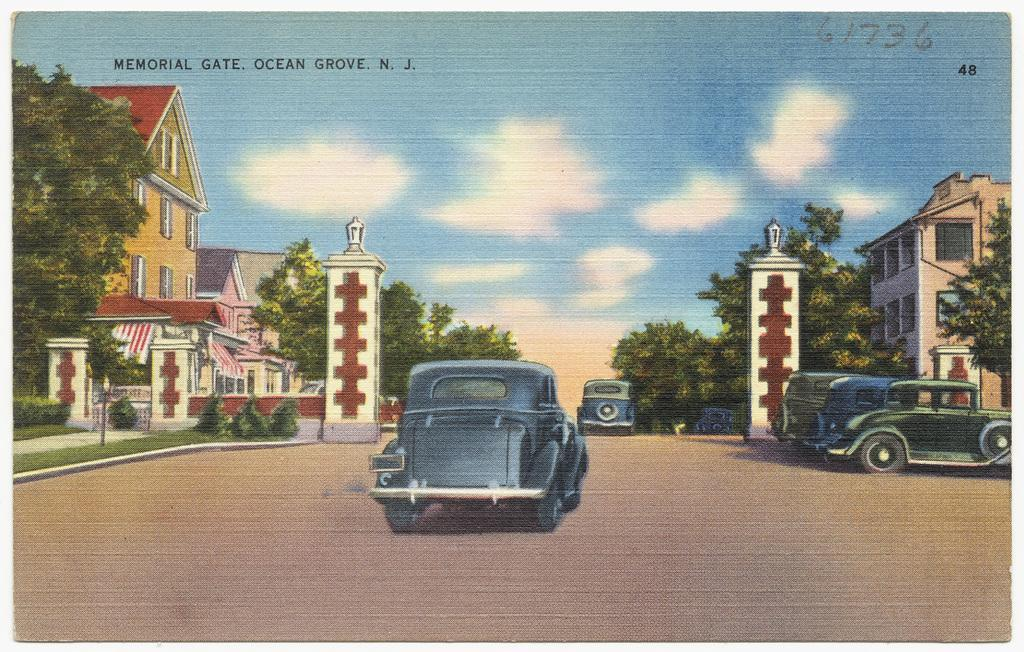What is the main subject of the image? The main subject of the image is a photo of cars parked on the road. What can be seen in the background of the image? In the background of the image, there is a group of trees and buildings. How would you describe the sky in the image? The sky in the image is cloudy. Is there any text present in the image? Yes, there is some text written on the image. What type of cheese is being served on the bread in the image? There is no cheese or bread present in the image; it features a photo of cars parked on the road with a cloudy sky and some text. What type of business is being conducted in the image? The image does not depict any business activity; it shows cars parked on the road with a background of trees, buildings, and a cloudy sky. 